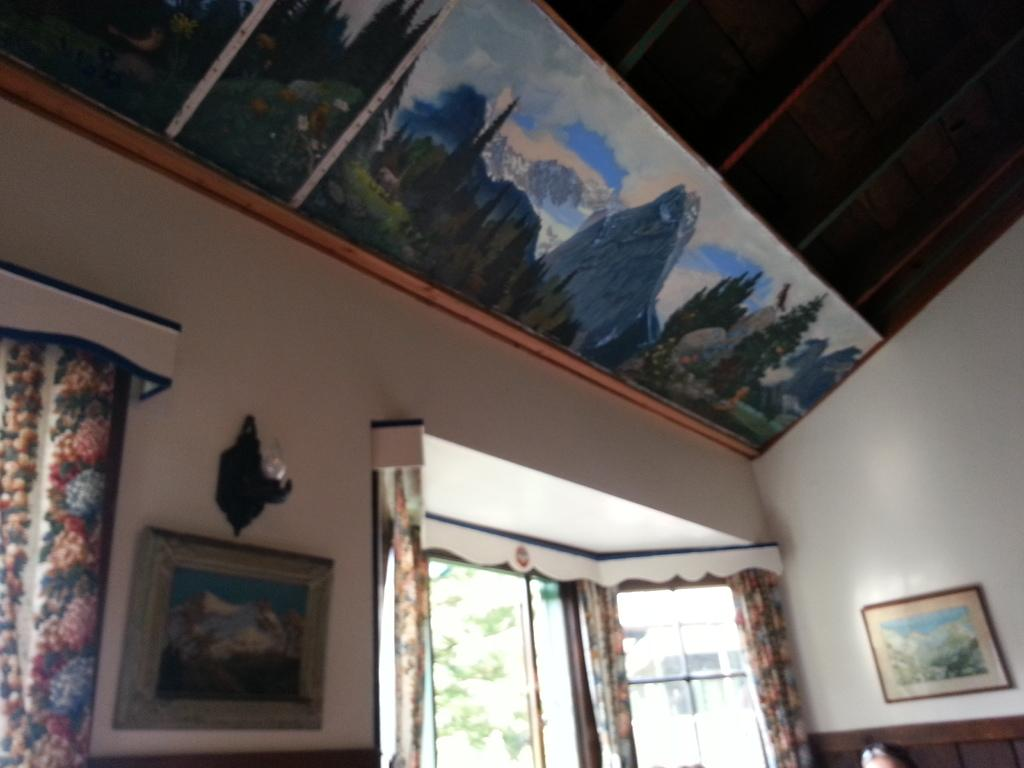What can be seen on the walls in the image? There are frames on the walls in the image. Can you describe the object on the wall? There is an object on the wall in the image, but the specifics are not mentioned in the facts. What type of window treatment is present in the image? There are curtains in the image. How many windows are visible in the image? There are windows in the image, but the exact number is not mentioned in the facts. What is on the ceiling in the image? There is a painting on the ceiling in the image. What type of appliance is visible on the farm in the image? There is no mention of a farm or an appliance in the image. What color is the tail of the animal in the image? There is no animal with a tail present in the image. 